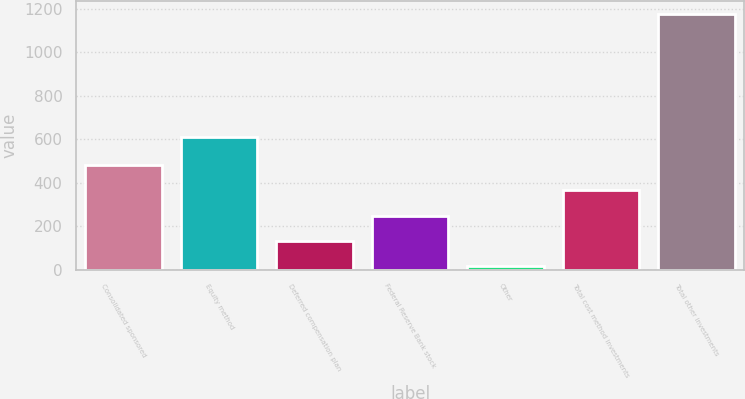Convert chart. <chart><loc_0><loc_0><loc_500><loc_500><bar_chart><fcel>Consolidated sponsored<fcel>Equity method<fcel>Deferred compensation plan<fcel>Federal Reserve Bank stock<fcel>Other<fcel>Total cost method investments<fcel>Total other investments<nl><fcel>481<fcel>613<fcel>133<fcel>249<fcel>17<fcel>365<fcel>1177<nl></chart> 